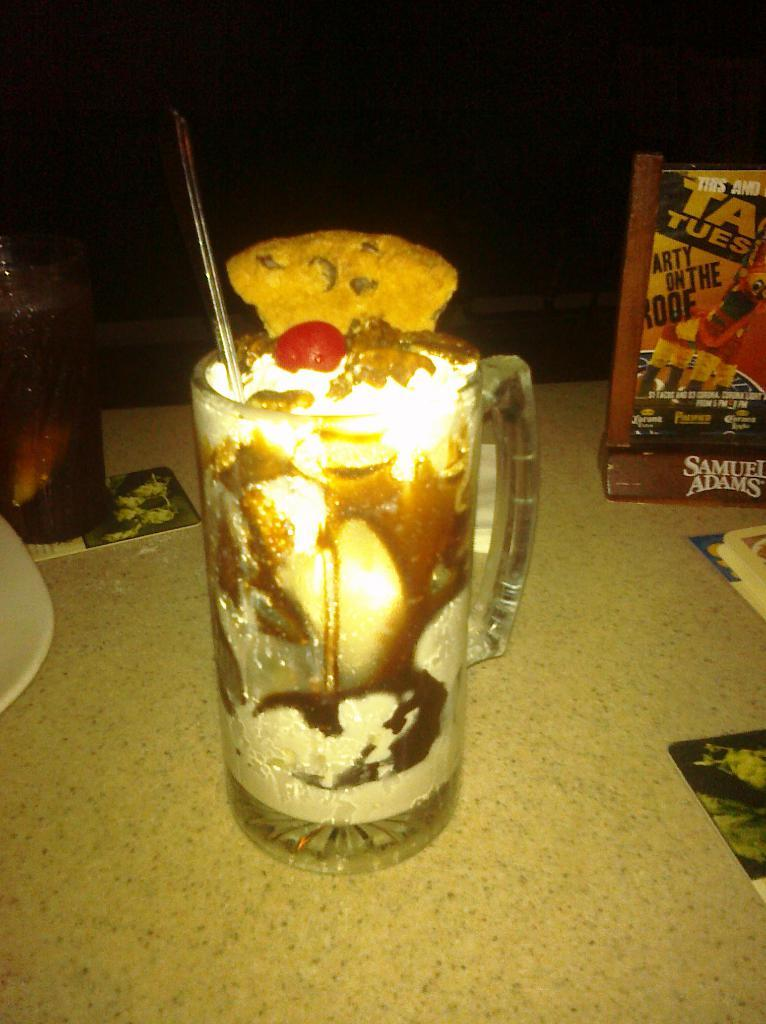Provide a one-sentence caption for the provided image. A glass containing a drink ready to serve to the ight of which is a box containing the letters TA TUES. 